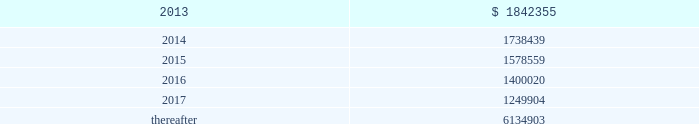Vornado realty trust notes to consolidated financial statements ( continued ) 20 .
Leases as lessor : we lease space to tenants under operating leases .
Most of the leases provide for the payment of fixed base rentals payable monthly in advance .
Office building leases generally require the tenants to reimburse us for operating costs and real estate taxes above their base year costs .
Shopping center leases provide for pass-through to tenants the tenant 2019s share of real estate taxes , insurance and maintenance .
Shopping center leases also provide for the payment by the lessee of additional rent based on a percentage of the tenants 2019 sales .
As of december 31 , 2012 , future base rental revenue under non-cancelable operating leases , excluding rents for leases with an original term of less than one year and rents resulting from the exercise of renewal options , are as follows : ( amounts in thousands ) year ending december 31: .
These amounts do not include percentage rentals based on tenants 2019 sales .
These percentage rents approximated $ 8466000 , $ 7995000 and $ 7339000 , for the years ended december 31 , 2012 , 2011 and 2010 , respectively .
None of our tenants accounted for more than 10% ( 10 % ) of total revenues in any of the years ended december 31 , 2012 , 2011 and 2010 .
Former bradlees locations pursuant to a master agreement and guaranty , dated may 1 , 1992 , we were due $ 5000000 of annual rent from stop & shop which was allocated to certain bradlees former locations .
On december 31 , 2002 , prior to the expiration of the leases to which the additional rent was allocated , we reallocated this rent to other former bradlees leases also guaranteed by stop & shop .
Stop & shop contested our right to reallocate the rent .
On november 7 , 2011 , the court determined that we had a continuing right to allocate the annual rent to unexpired leases covered by the master agreement and guaranty and directed entry of a judgment in our favor ordering stop & shop to pay us the unpaid annual rent .
At december 31 , 2012 , we had a $ 47900000 receivable from stop and shop , which is included as a component of 201ctenant and other receivables 201d on our consolidated balance sheet .
On february 6 , 2013 , we received $ 124000000 pursuant to a settlement agreement with stop & shop ( see note 22 2013 commitments and contingencies 2013 litigation ) . .
For 2012 and 2011 , percentage rentals based on tenants 2019 sales totaled what in thousands? 
Computations: (8466000 + 7995000)
Answer: 16461000.0. 